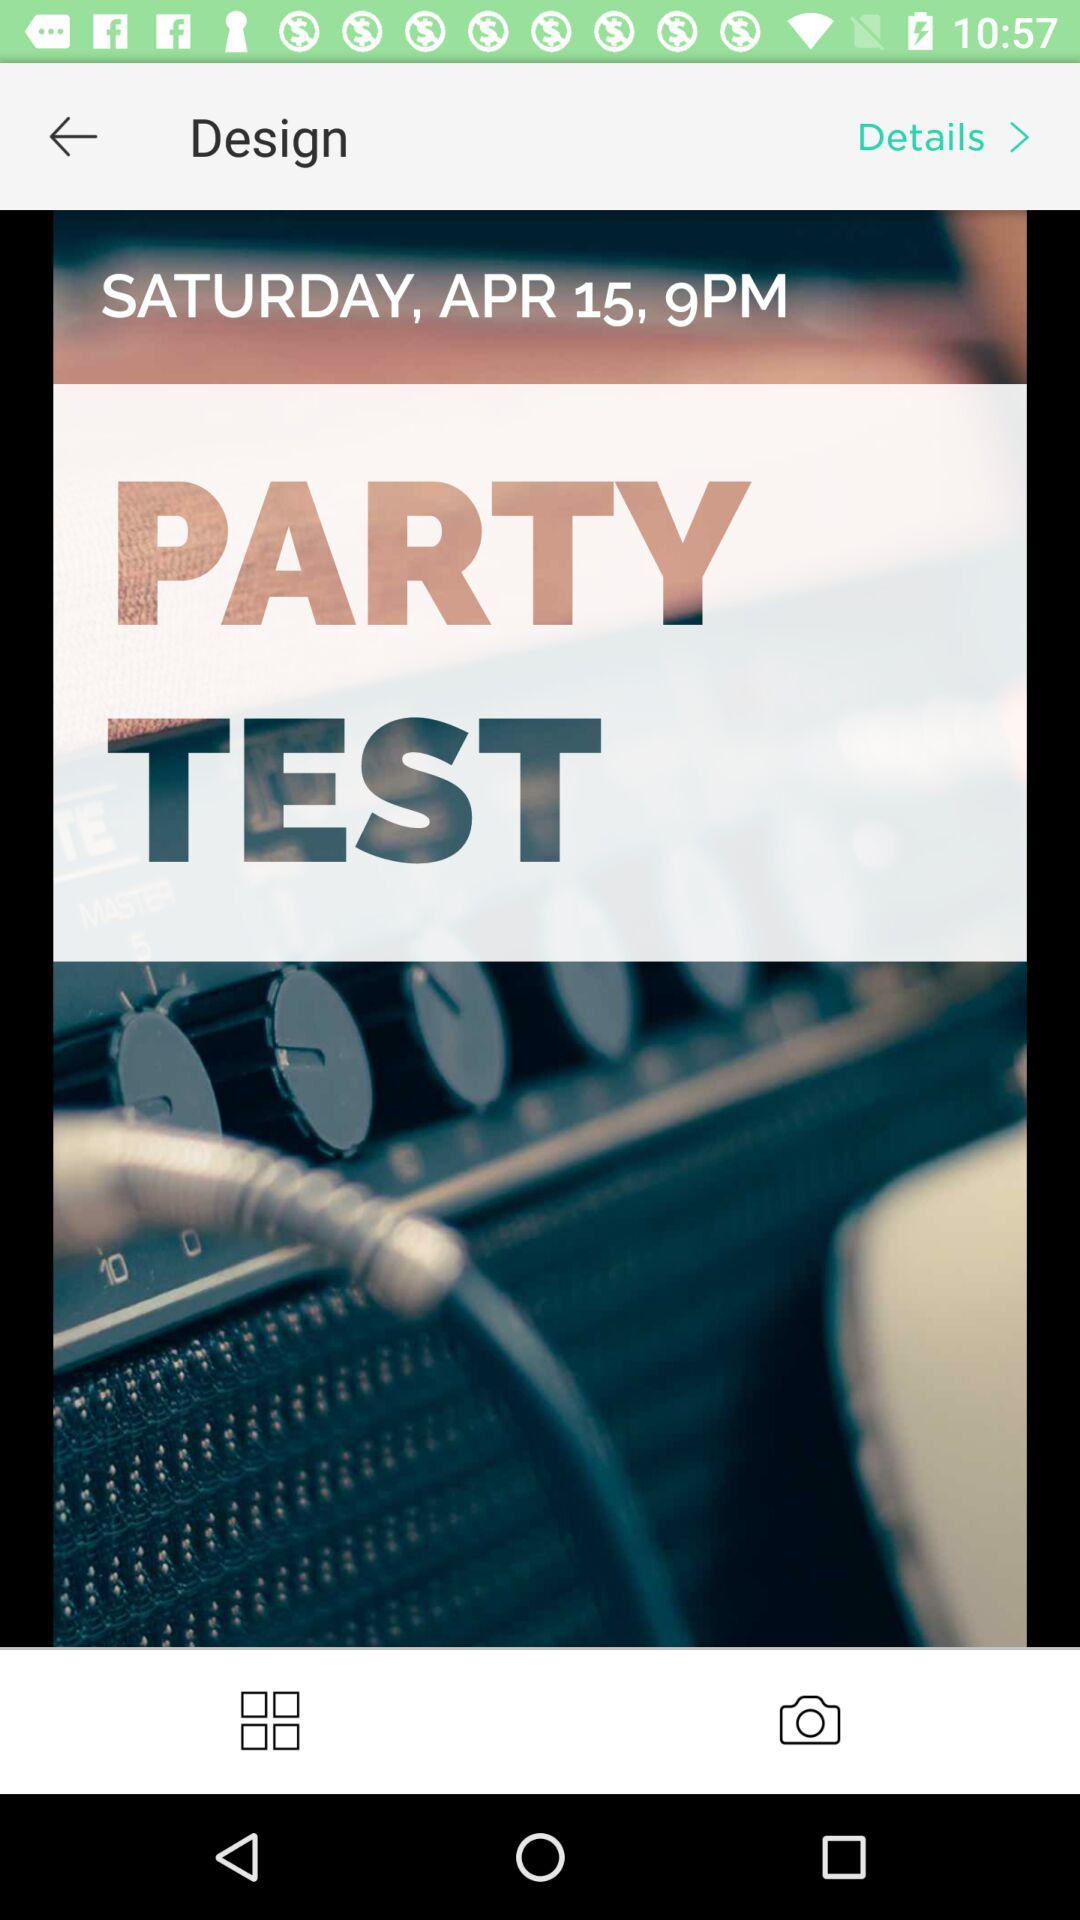What is the date given? The given date is Saturday, April 15. 